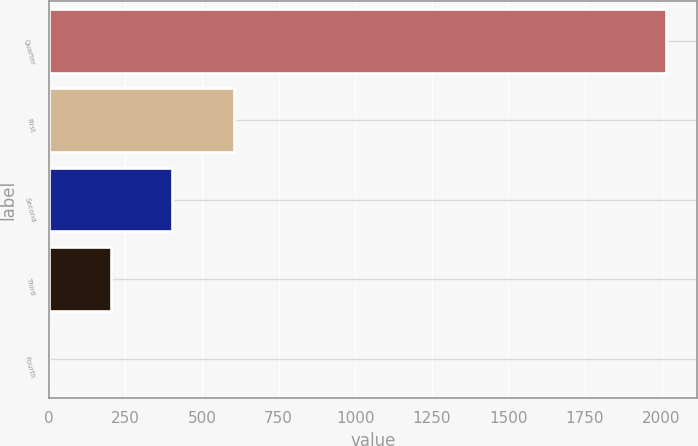Convert chart to OTSL. <chart><loc_0><loc_0><loc_500><loc_500><bar_chart><fcel>Quarter<fcel>First<fcel>Second<fcel>Third<fcel>Fourth<nl><fcel>2016<fcel>605.5<fcel>404<fcel>202.5<fcel>1<nl></chart> 